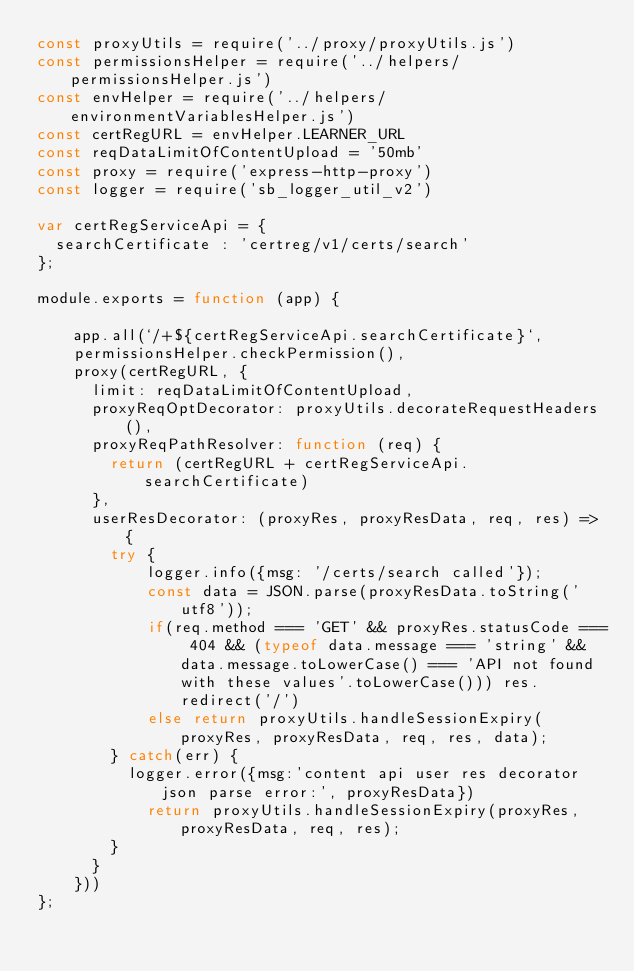Convert code to text. <code><loc_0><loc_0><loc_500><loc_500><_JavaScript_>const proxyUtils = require('../proxy/proxyUtils.js')
const permissionsHelper = require('../helpers/permissionsHelper.js')
const envHelper = require('../helpers/environmentVariablesHelper.js')
const certRegURL = envHelper.LEARNER_URL
const reqDataLimitOfContentUpload = '50mb'
const proxy = require('express-http-proxy')
const logger = require('sb_logger_util_v2')

var certRegServiceApi = {
  searchCertificate : 'certreg/v1/certs/search'
};

module.exports = function (app) {

    app.all(`/+${certRegServiceApi.searchCertificate}`,
    permissionsHelper.checkPermission(),
    proxy(certRegURL, {
      limit: reqDataLimitOfContentUpload,
      proxyReqOptDecorator: proxyUtils.decorateRequestHeaders(),
      proxyReqPathResolver: function (req) {
        return (certRegURL + certRegServiceApi.searchCertificate)
      },
      userResDecorator: (proxyRes, proxyResData, req, res) => {
        try {
            logger.info({msg: '/certs/search called'});
            const data = JSON.parse(proxyResData.toString('utf8'));
            if(req.method === 'GET' && proxyRes.statusCode === 404 && (typeof data.message === 'string' && data.message.toLowerCase() === 'API not found with these values'.toLowerCase())) res.redirect('/')
            else return proxyUtils.handleSessionExpiry(proxyRes, proxyResData, req, res, data);
        } catch(err) {
          logger.error({msg:'content api user res decorator json parse error:', proxyResData})
            return proxyUtils.handleSessionExpiry(proxyRes, proxyResData, req, res);
        }
      }
    }))
};
</code> 